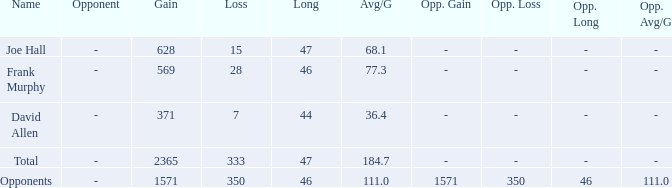Which Avg/G has a Name of david allen, and a Gain larger than 371? None. 